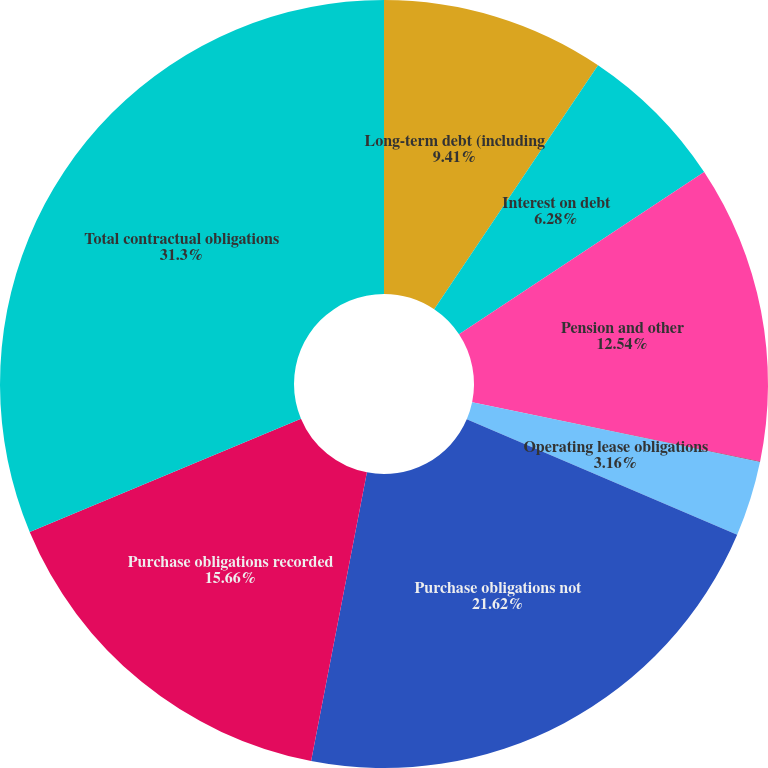Convert chart to OTSL. <chart><loc_0><loc_0><loc_500><loc_500><pie_chart><fcel>Long-term debt (including<fcel>Interest on debt<fcel>Pension and other<fcel>Capital lease obligations<fcel>Operating lease obligations<fcel>Purchase obligations not<fcel>Purchase obligations recorded<fcel>Total contractual obligations<nl><fcel>9.41%<fcel>6.28%<fcel>12.54%<fcel>0.03%<fcel>3.16%<fcel>21.62%<fcel>15.66%<fcel>31.3%<nl></chart> 